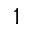Convert formula to latex. <formula><loc_0><loc_0><loc_500><loc_500>^ { 1 }</formula> 